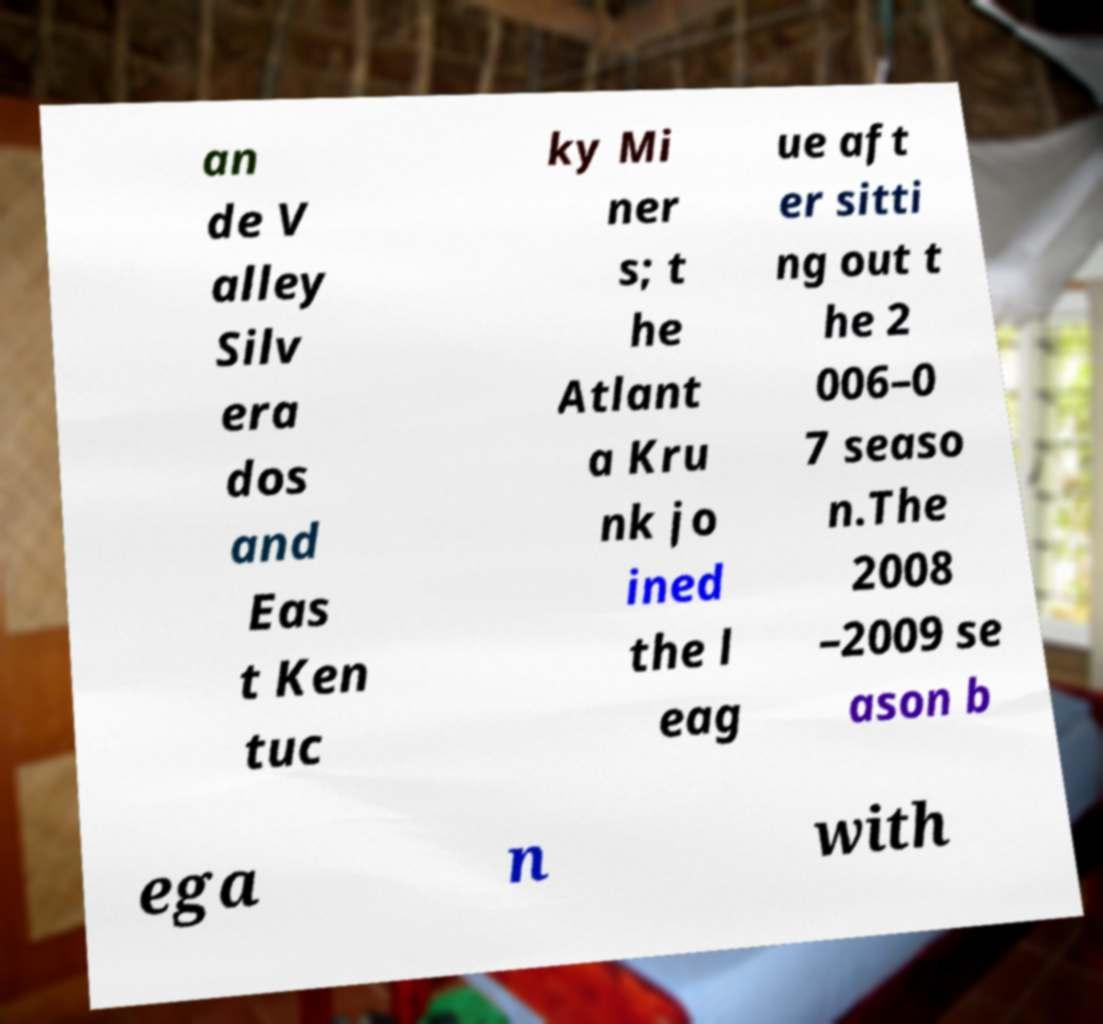For documentation purposes, I need the text within this image transcribed. Could you provide that? an de V alley Silv era dos and Eas t Ken tuc ky Mi ner s; t he Atlant a Kru nk jo ined the l eag ue aft er sitti ng out t he 2 006–0 7 seaso n.The 2008 –2009 se ason b ega n with 